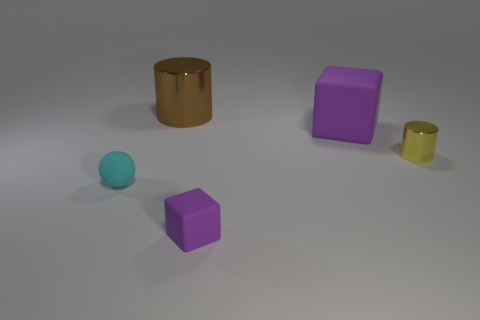Add 4 small cyan matte balls. How many objects exist? 9 Subtract all blocks. How many objects are left? 3 Subtract all big cyan spheres. Subtract all large objects. How many objects are left? 3 Add 1 big objects. How many big objects are left? 3 Add 1 blocks. How many blocks exist? 3 Subtract 0 purple spheres. How many objects are left? 5 